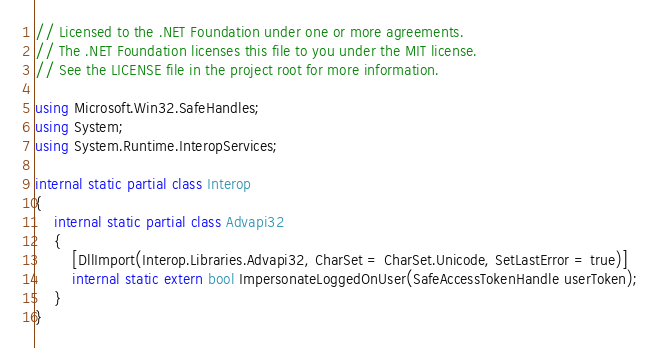Convert code to text. <code><loc_0><loc_0><loc_500><loc_500><_C#_>// Licensed to the .NET Foundation under one or more agreements.
// The .NET Foundation licenses this file to you under the MIT license.
// See the LICENSE file in the project root for more information.

using Microsoft.Win32.SafeHandles;
using System;
using System.Runtime.InteropServices;

internal static partial class Interop
{
    internal static partial class Advapi32
    {
        [DllImport(Interop.Libraries.Advapi32, CharSet = CharSet.Unicode, SetLastError = true)]
        internal static extern bool ImpersonateLoggedOnUser(SafeAccessTokenHandle userToken);
    }
}
</code> 